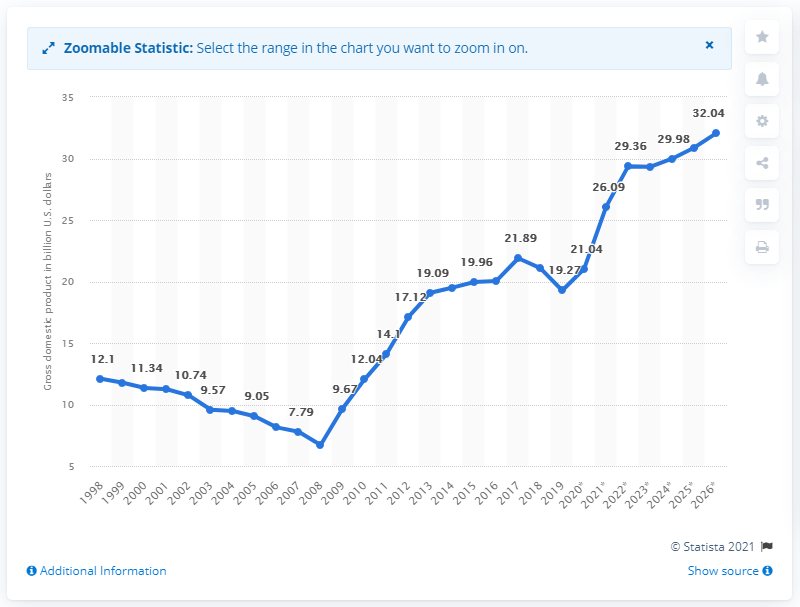Highlight a few significant elements in this photo. In 2019, the gross domestic product of Zimbabwe was approximately 19.27 billion dollars. 